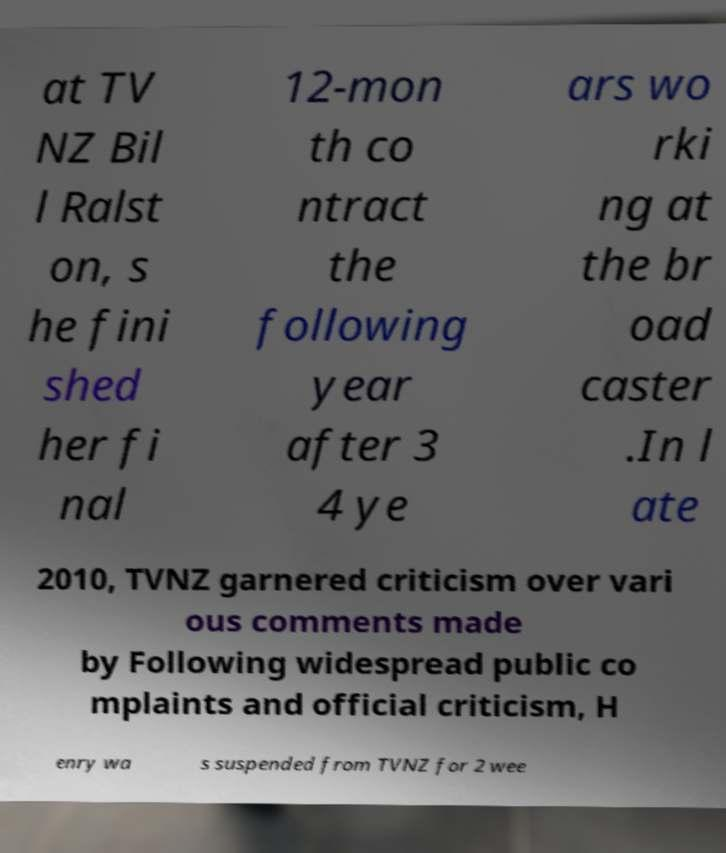I need the written content from this picture converted into text. Can you do that? at TV NZ Bil l Ralst on, s he fini shed her fi nal 12-mon th co ntract the following year after 3 4 ye ars wo rki ng at the br oad caster .In l ate 2010, TVNZ garnered criticism over vari ous comments made by Following widespread public co mplaints and official criticism, H enry wa s suspended from TVNZ for 2 wee 